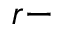Convert formula to latex. <formula><loc_0><loc_0><loc_500><loc_500>r -</formula> 